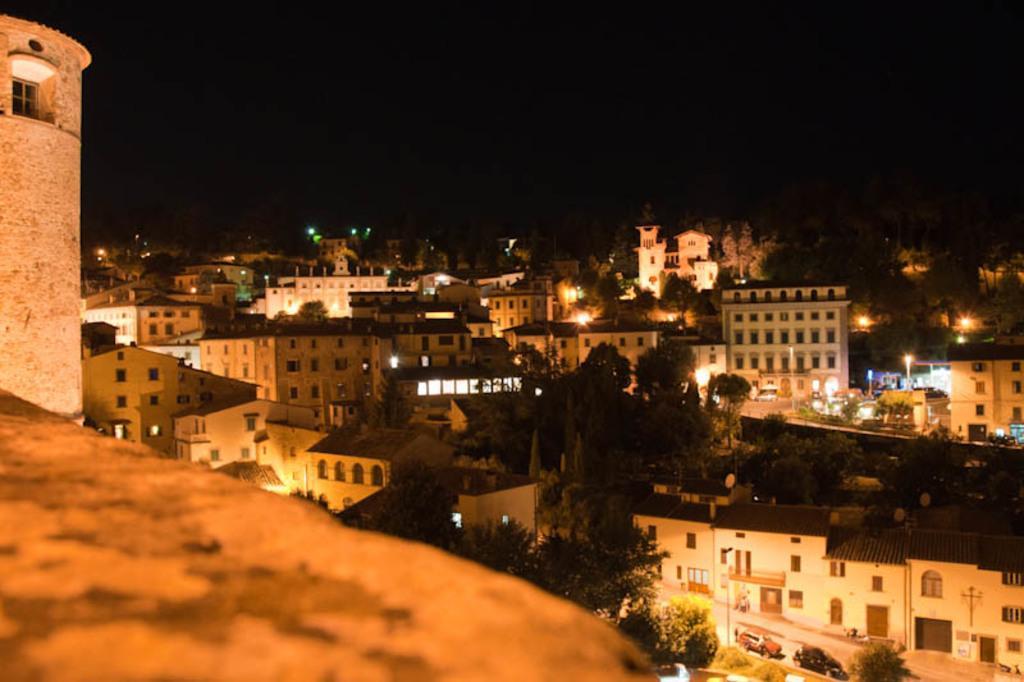Can you describe this image briefly? In this picture we can see some buildings, trees and lights, at the bottom there are two cars here, we can see the sky at the top of the picture. 